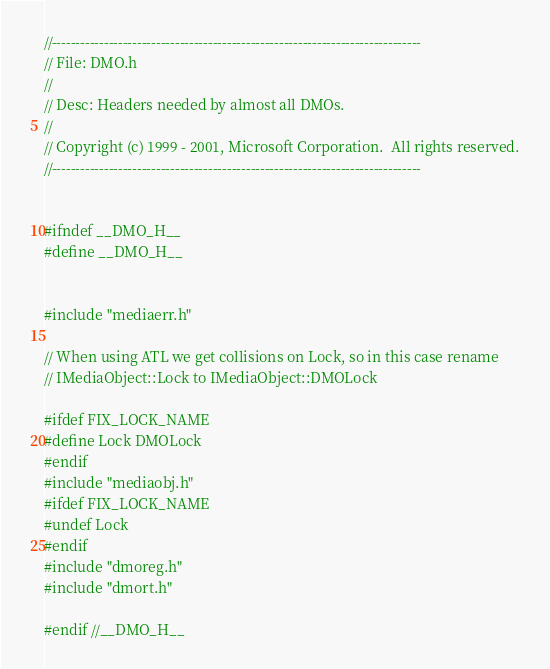Convert code to text. <code><loc_0><loc_0><loc_500><loc_500><_C_>//------------------------------------------------------------------------------
// File: DMO.h
//
// Desc: Headers needed by almost all DMOs.
//
// Copyright (c) 1999 - 2001, Microsoft Corporation.  All rights reserved.
//------------------------------------------------------------------------------


#ifndef __DMO_H__
#define __DMO_H__


#include "mediaerr.h"

// When using ATL we get collisions on Lock, so in this case rename
// IMediaObject::Lock to IMediaObject::DMOLock

#ifdef FIX_LOCK_NAME
#define Lock DMOLock
#endif
#include "mediaobj.h"
#ifdef FIX_LOCK_NAME
#undef Lock
#endif
#include "dmoreg.h"
#include "dmort.h"

#endif //__DMO_H__

</code> 